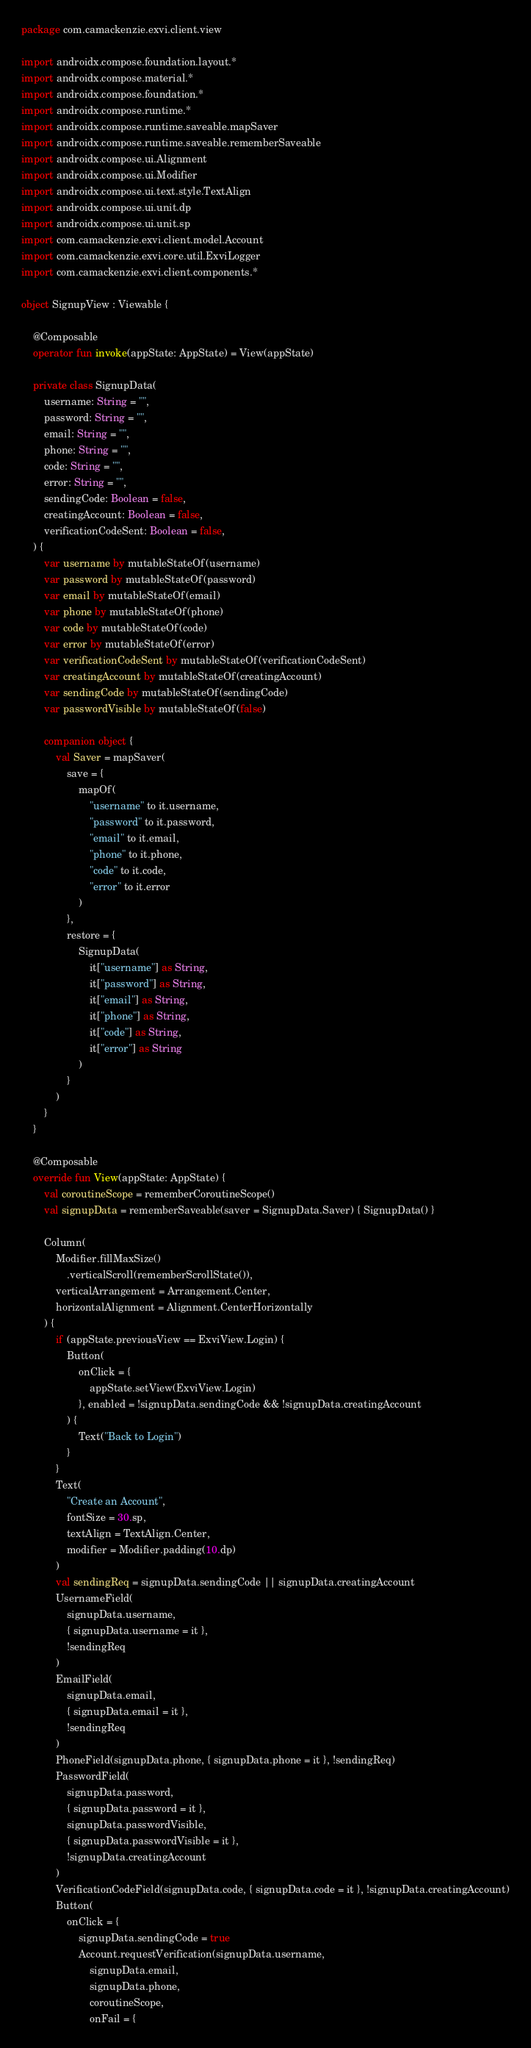Convert code to text. <code><loc_0><loc_0><loc_500><loc_500><_Kotlin_>package com.camackenzie.exvi.client.view

import androidx.compose.foundation.layout.*
import androidx.compose.material.*
import androidx.compose.foundation.*
import androidx.compose.runtime.*
import androidx.compose.runtime.saveable.mapSaver
import androidx.compose.runtime.saveable.rememberSaveable
import androidx.compose.ui.Alignment
import androidx.compose.ui.Modifier
import androidx.compose.ui.text.style.TextAlign
import androidx.compose.ui.unit.dp
import androidx.compose.ui.unit.sp
import com.camackenzie.exvi.client.model.Account
import com.camackenzie.exvi.core.util.ExviLogger
import com.camackenzie.exvi.client.components.*

object SignupView : Viewable {

    @Composable
    operator fun invoke(appState: AppState) = View(appState)

    private class SignupData(
        username: String = "",
        password: String = "",
        email: String = "",
        phone: String = "",
        code: String = "",
        error: String = "",
        sendingCode: Boolean = false,
        creatingAccount: Boolean = false,
        verificationCodeSent: Boolean = false,
    ) {
        var username by mutableStateOf(username)
        var password by mutableStateOf(password)
        var email by mutableStateOf(email)
        var phone by mutableStateOf(phone)
        var code by mutableStateOf(code)
        var error by mutableStateOf(error)
        var verificationCodeSent by mutableStateOf(verificationCodeSent)
        var creatingAccount by mutableStateOf(creatingAccount)
        var sendingCode by mutableStateOf(sendingCode)
        var passwordVisible by mutableStateOf(false)

        companion object {
            val Saver = mapSaver(
                save = {
                    mapOf(
                        "username" to it.username,
                        "password" to it.password,
                        "email" to it.email,
                        "phone" to it.phone,
                        "code" to it.code,
                        "error" to it.error
                    )
                },
                restore = {
                    SignupData(
                        it["username"] as String,
                        it["password"] as String,
                        it["email"] as String,
                        it["phone"] as String,
                        it["code"] as String,
                        it["error"] as String
                    )
                }
            )
        }
    }

    @Composable
    override fun View(appState: AppState) {
        val coroutineScope = rememberCoroutineScope()
        val signupData = rememberSaveable(saver = SignupData.Saver) { SignupData() }

        Column(
            Modifier.fillMaxSize()
                .verticalScroll(rememberScrollState()),
            verticalArrangement = Arrangement.Center,
            horizontalAlignment = Alignment.CenterHorizontally
        ) {
            if (appState.previousView == ExviView.Login) {
                Button(
                    onClick = {
                        appState.setView(ExviView.Login)
                    }, enabled = !signupData.sendingCode && !signupData.creatingAccount
                ) {
                    Text("Back to Login")
                }
            }
            Text(
                "Create an Account",
                fontSize = 30.sp,
                textAlign = TextAlign.Center,
                modifier = Modifier.padding(10.dp)
            )
            val sendingReq = signupData.sendingCode || signupData.creatingAccount
            UsernameField(
                signupData.username,
                { signupData.username = it },
                !sendingReq
            )
            EmailField(
                signupData.email,
                { signupData.email = it },
                !sendingReq
            )
            PhoneField(signupData.phone, { signupData.phone = it }, !sendingReq)
            PasswordField(
                signupData.password,
                { signupData.password = it },
                signupData.passwordVisible,
                { signupData.passwordVisible = it },
                !signupData.creatingAccount
            )
            VerificationCodeField(signupData.code, { signupData.code = it }, !signupData.creatingAccount)
            Button(
                onClick = {
                    signupData.sendingCode = true
                    Account.requestVerification(signupData.username,
                        signupData.email,
                        signupData.phone,
                        coroutineScope,
                        onFail = {</code> 